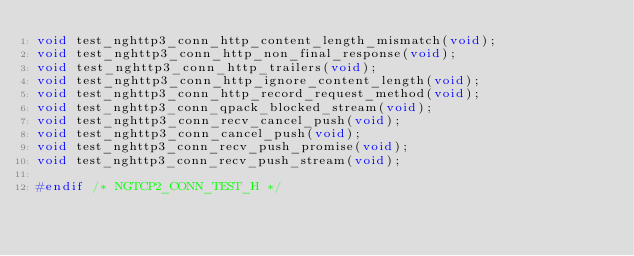<code> <loc_0><loc_0><loc_500><loc_500><_C_>void test_nghttp3_conn_http_content_length_mismatch(void);
void test_nghttp3_conn_http_non_final_response(void);
void test_nghttp3_conn_http_trailers(void);
void test_nghttp3_conn_http_ignore_content_length(void);
void test_nghttp3_conn_http_record_request_method(void);
void test_nghttp3_conn_qpack_blocked_stream(void);
void test_nghttp3_conn_recv_cancel_push(void);
void test_nghttp3_conn_cancel_push(void);
void test_nghttp3_conn_recv_push_promise(void);
void test_nghttp3_conn_recv_push_stream(void);

#endif /* NGTCP2_CONN_TEST_H */
</code> 